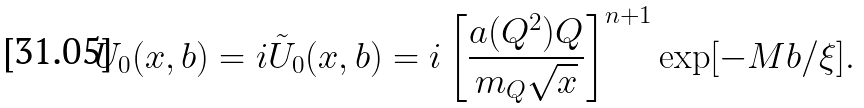<formula> <loc_0><loc_0><loc_500><loc_500>U _ { 0 } ( x , b ) = i \tilde { U } _ { 0 } ( x , b ) = i \left [ \frac { a ( Q ^ { 2 } ) Q } { m _ { Q } \sqrt { x } } \right ] ^ { n + 1 } \exp [ - M b / \xi ] .</formula> 